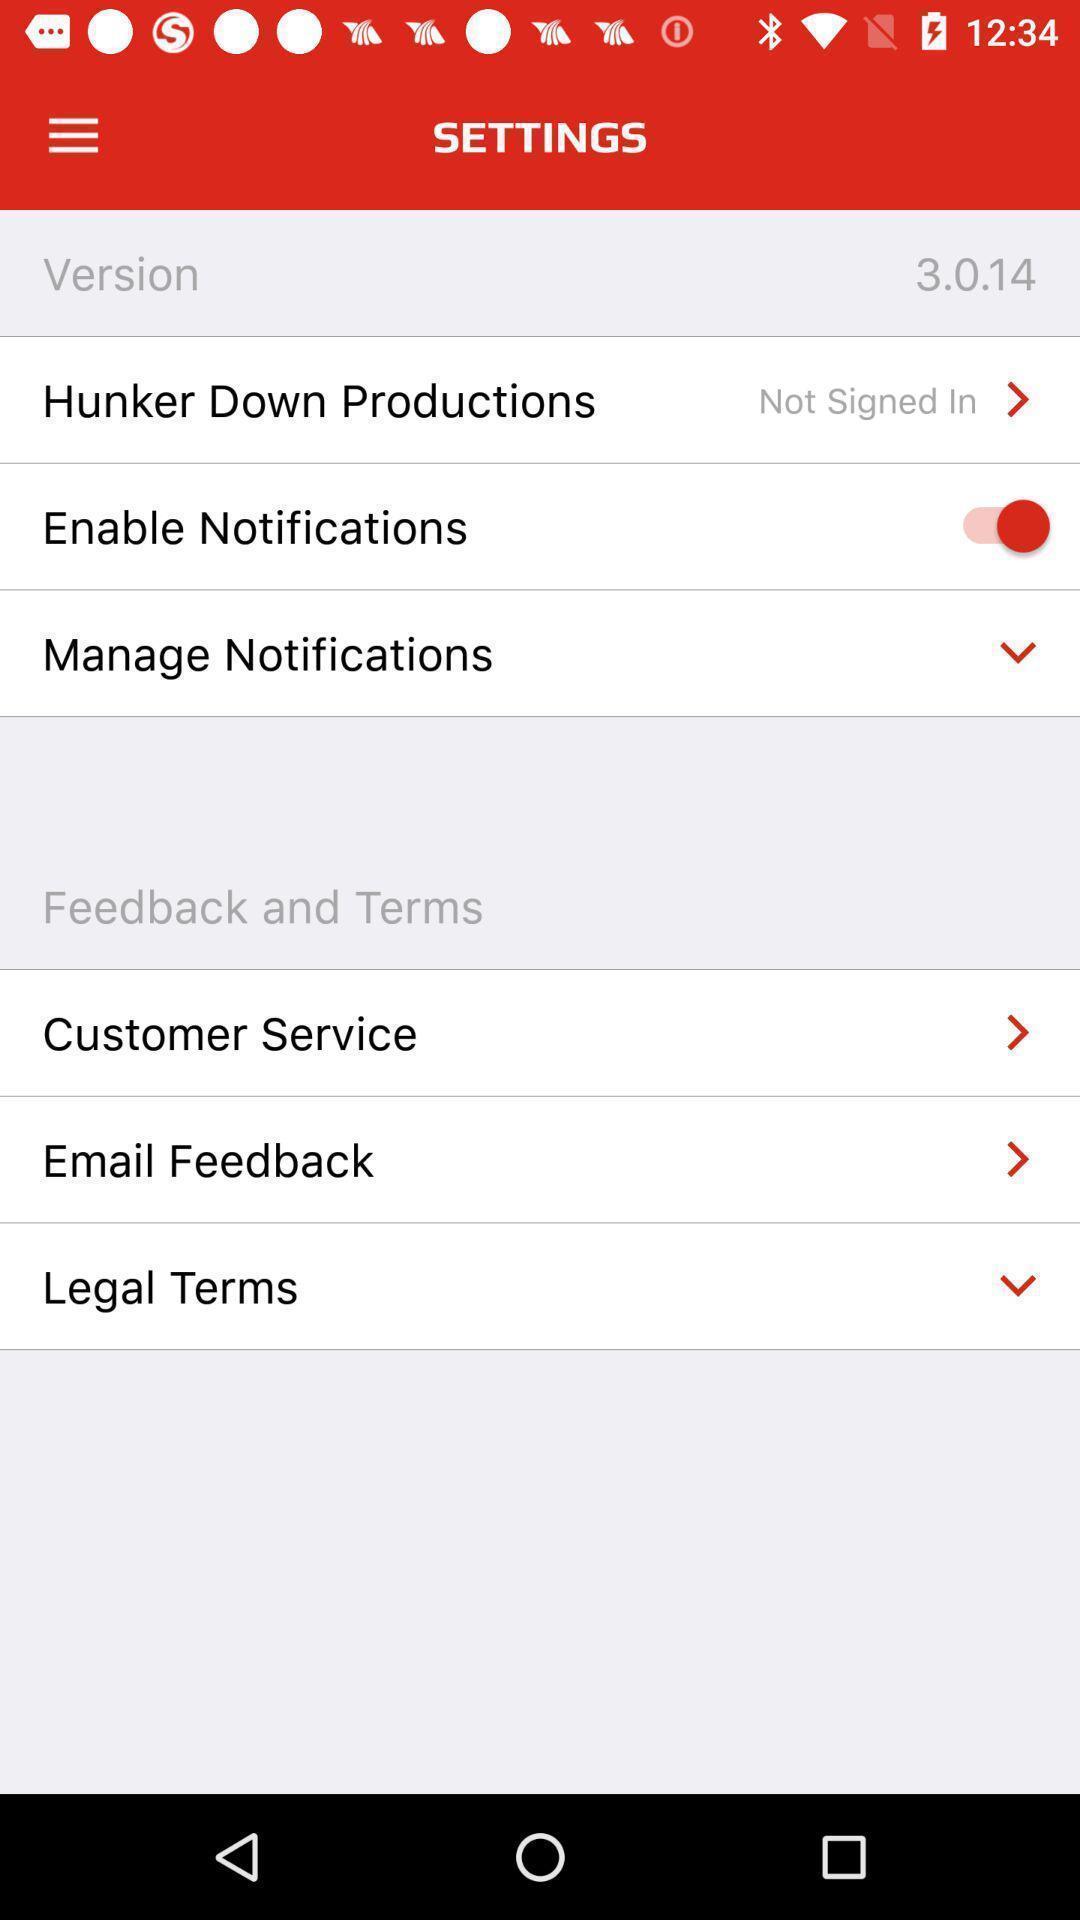Give me a summary of this screen capture. Settings page. 